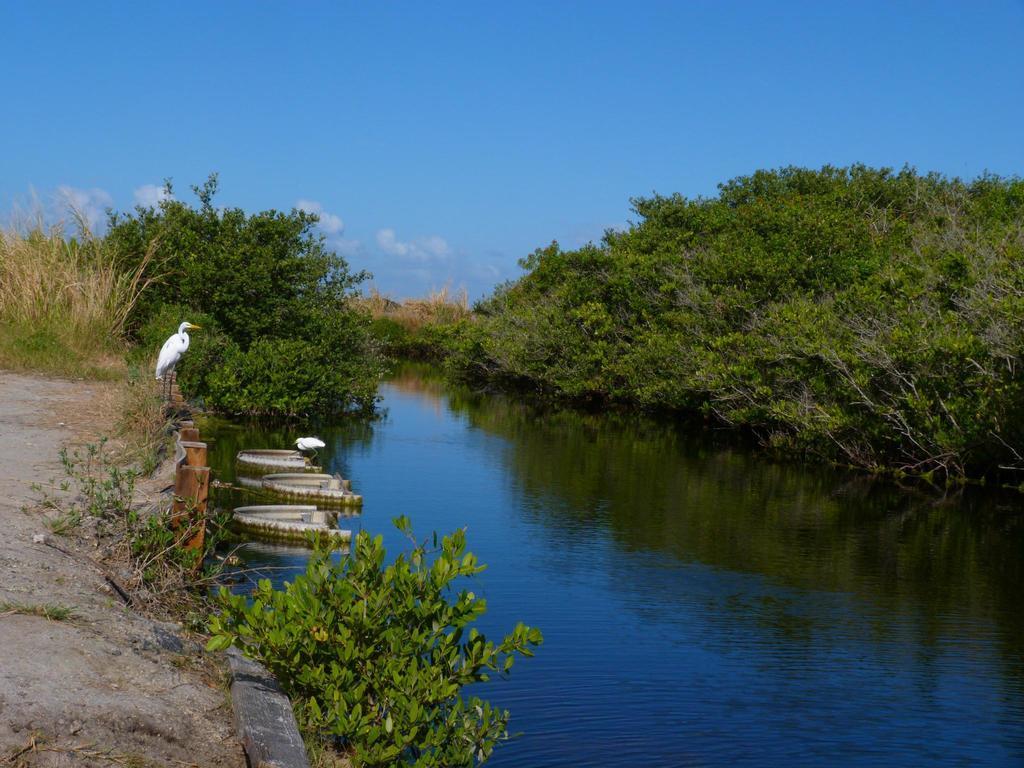Please provide a concise description of this image. Here in this picture we can see a river present, as we can see water present over there and in that river we can see some boats and some cranes present over there and on either side of it we can see plants and trees present all over there and we can also see clouds in the sky. 